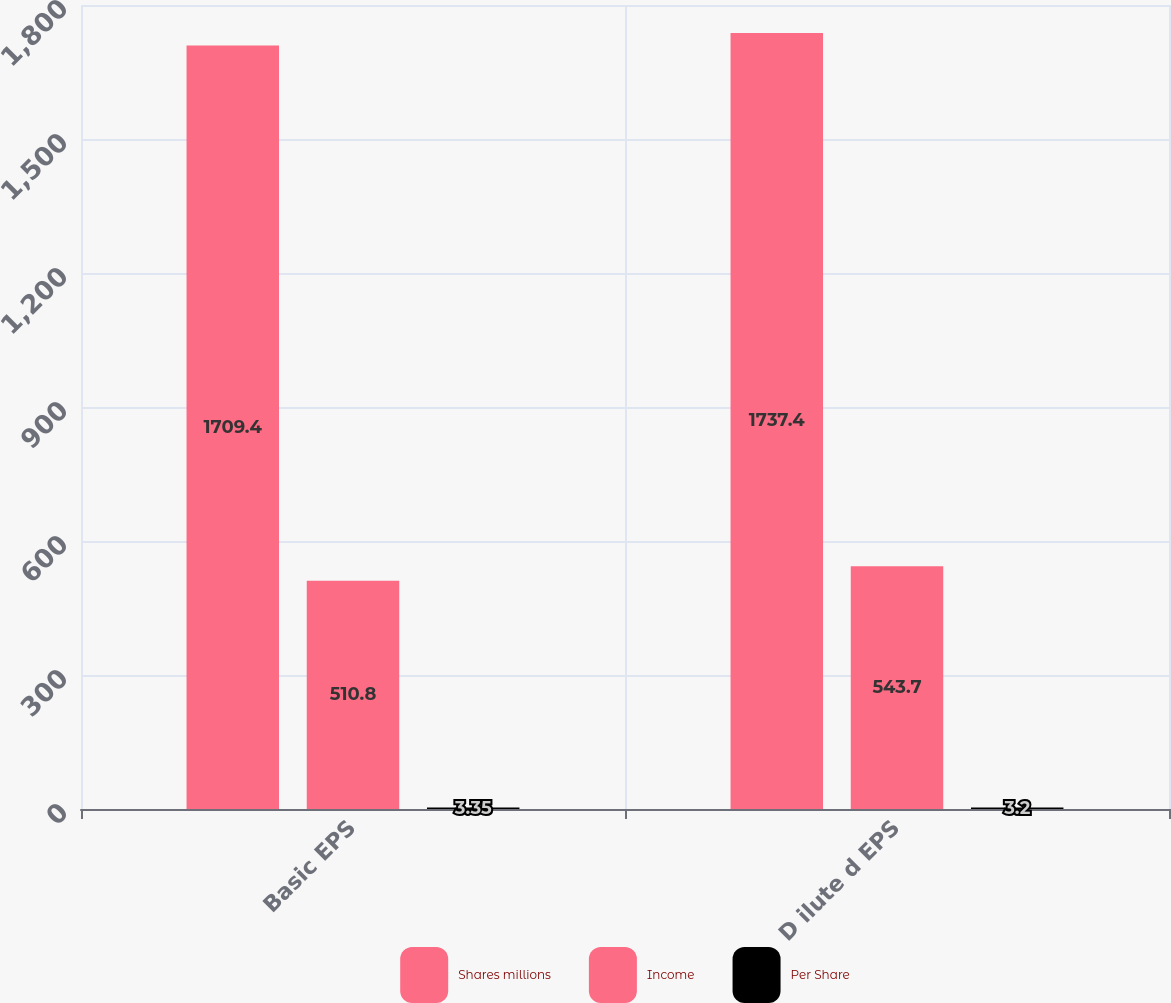<chart> <loc_0><loc_0><loc_500><loc_500><stacked_bar_chart><ecel><fcel>Basic EPS<fcel>D ilute d EPS<nl><fcel>Shares millions<fcel>1709.4<fcel>1737.4<nl><fcel>Income<fcel>510.8<fcel>543.7<nl><fcel>Per Share<fcel>3.35<fcel>3.2<nl></chart> 